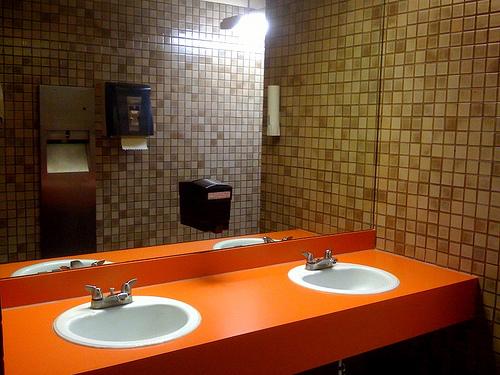Is this a restaurant or home?
Give a very brief answer. Restaurant. Are the sinks automatic?
Keep it brief. No. How many different shades are the tiles?
Give a very brief answer. 4. 